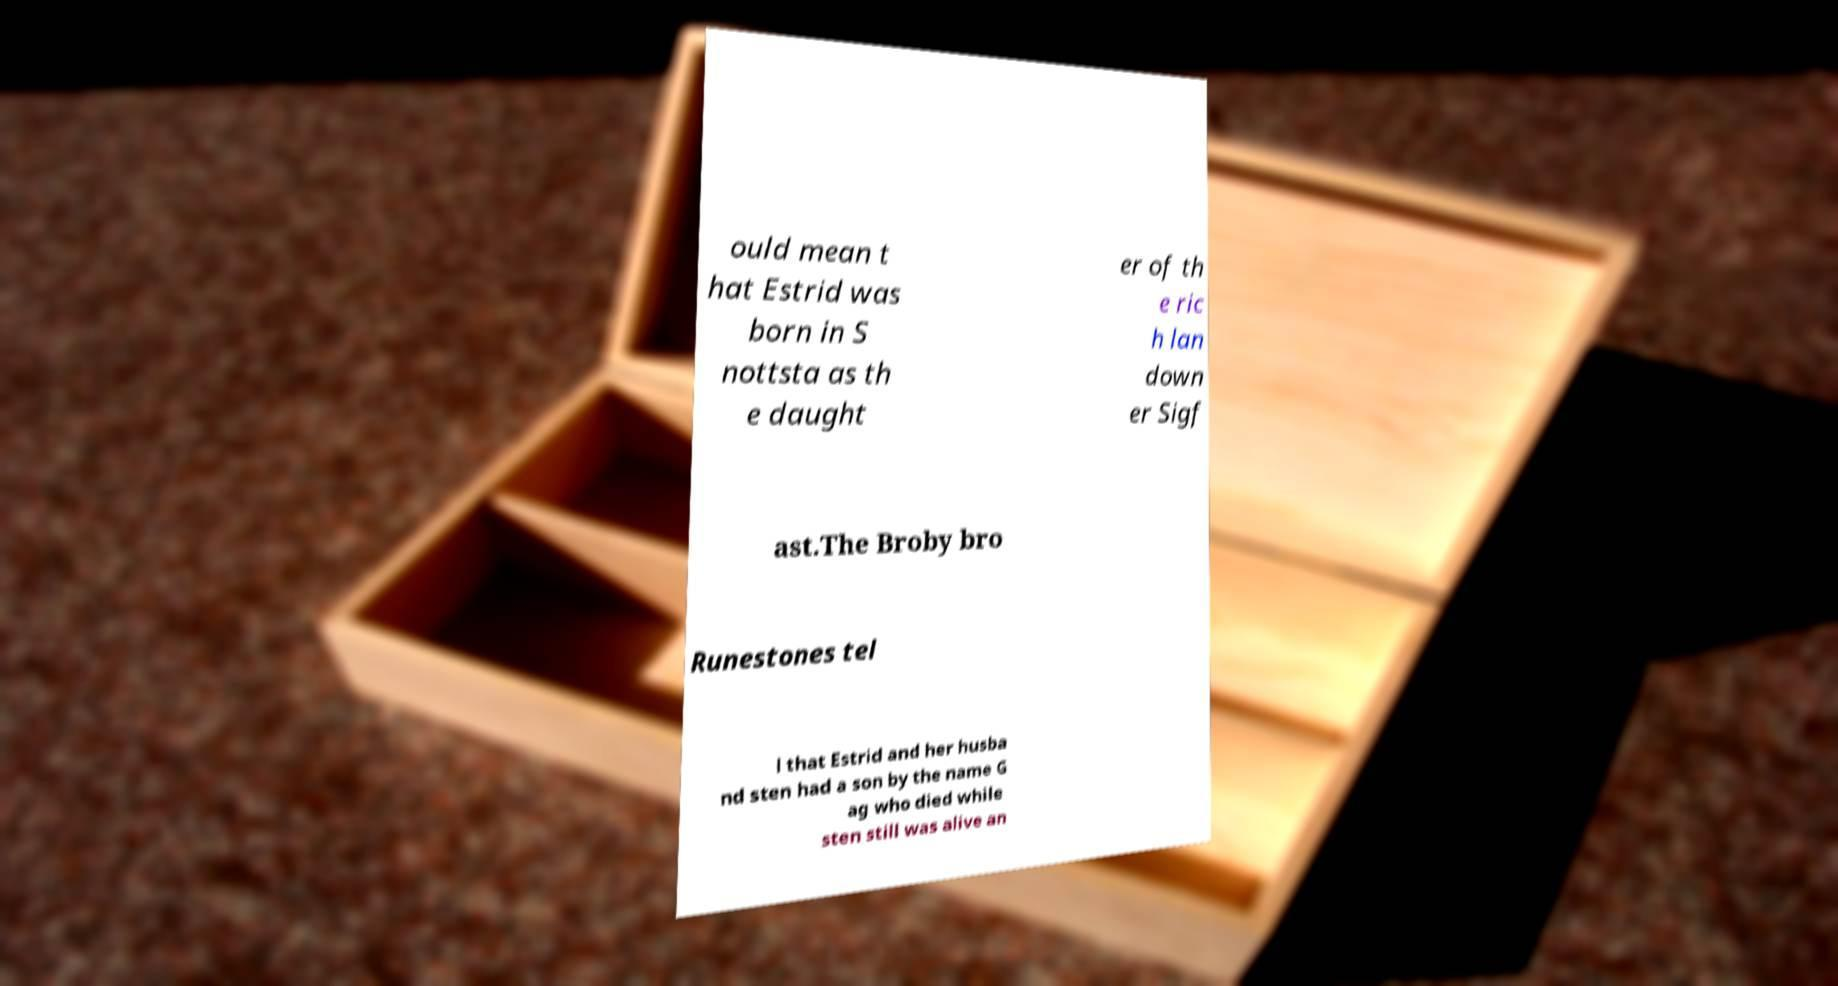Can you accurately transcribe the text from the provided image for me? ould mean t hat Estrid was born in S nottsta as th e daught er of th e ric h lan down er Sigf ast.The Broby bro Runestones tel l that Estrid and her husba nd sten had a son by the name G ag who died while sten still was alive an 